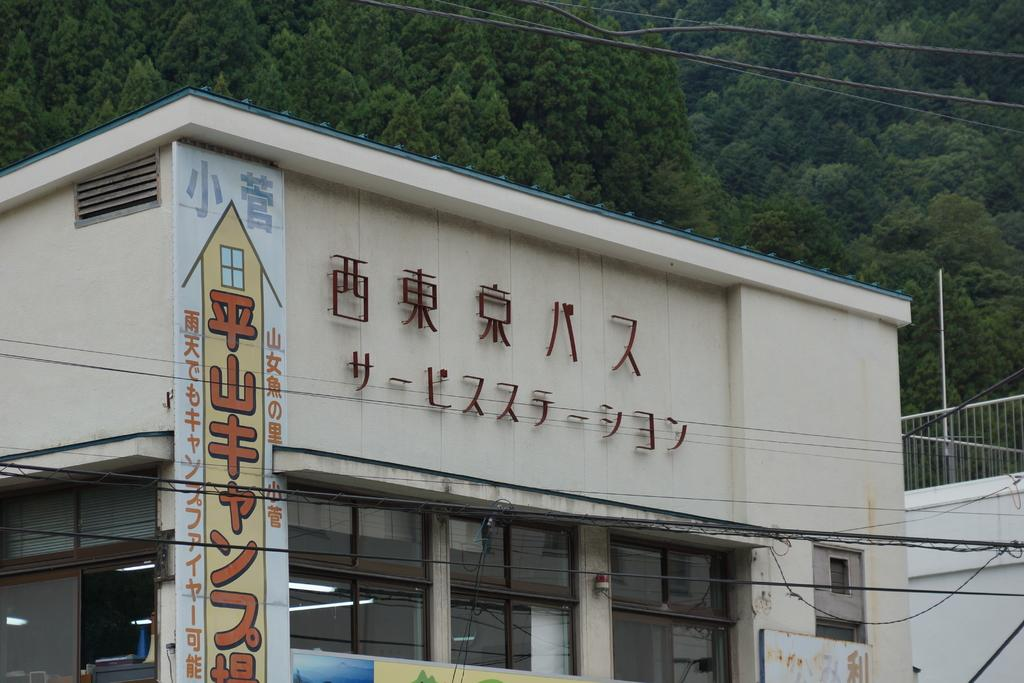What type of structure is in the image? There is a building in the image. What can be seen near the building? There are grills and trees visible in the image. What type of lighting is present in the image? Electric lights are visible in the image. Are there any electrical components in the image? Yes, electric cables are present in the image. What type of lace is draped over the trees in the image? There is no lace present in the image; it only features a building, grills, electric lights, and electric cables. 